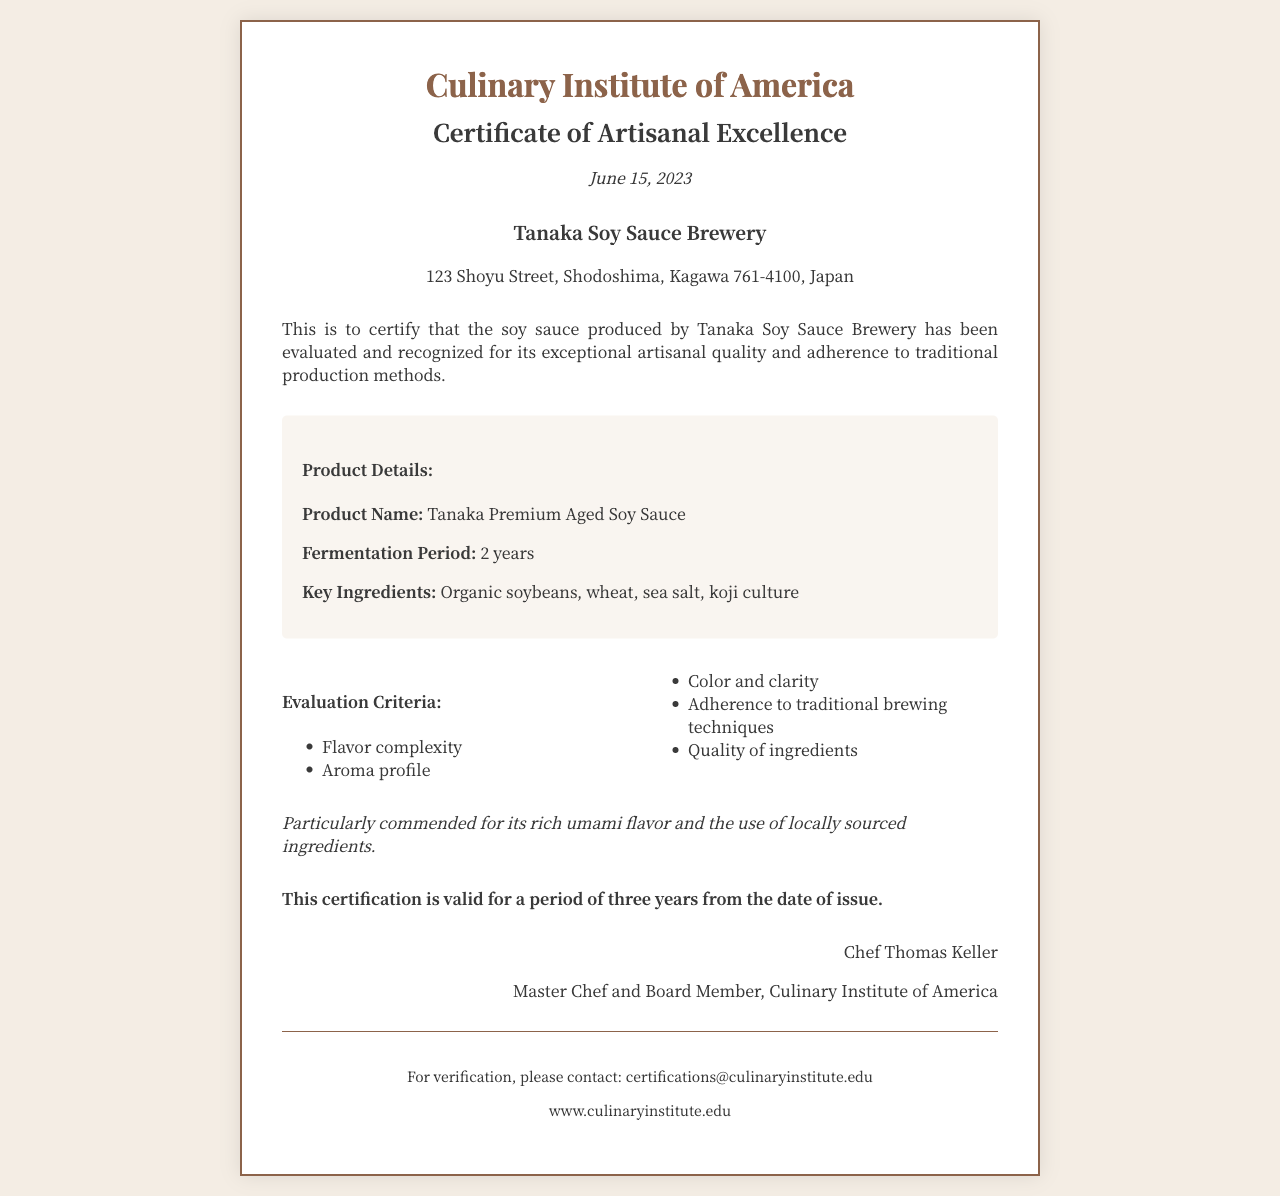What is the name of the issuing institute? The document is issued by the Culinary Institute of America, as stated in the header.
Answer: Culinary Institute of America Who is the recipient of the certificate? The recipient's name can be found just below the header, indicating who the certificate is awarded to.
Answer: Tanaka Soy Sauce Brewery What is the product name mentioned in the document? The document includes specific product details, which reveals the name of the soy sauce.
Answer: Tanaka Premium Aged Soy Sauce What is the fermentation period of the soy sauce? The fermentation period is listed under the product details section of the document.
Answer: 2 years How long is the certification valid? The validity period of the certification is stated clearly in the document.
Answer: Three years Which two ingredients are highlighted as part of the key ingredients? The document specifies key ingredients, allowing for identification of two main components.
Answer: Organic soybeans, wheat What were the criteria used for evaluation? The evaluation criteria are listed in a dedicated section, outlining the aspects on which the soy sauce was judged.
Answer: Flavor complexity, Aroma profile, Color and clarity, Adherence to traditional brewing techniques, Quality of ingredients Who signed the certificate? The signature section of the document indicates the individual who confirmed the certification.
Answer: Chef Thomas Keller What special commendation is noted in the document? A specific commendation regarding the soy sauce is mentioned in a special notes section.
Answer: Rich umami flavor and the use of locally sourced ingredients 